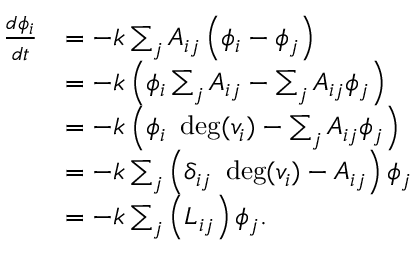<formula> <loc_0><loc_0><loc_500><loc_500>{ \begin{array} { r l } { { \frac { d \phi _ { i } } { d t } } } & { = - k \sum _ { j } A _ { i j } \left ( \phi _ { i } - \phi _ { j } \right ) } \\ & { = - k \left ( \phi _ { i } \sum _ { j } A _ { i j } - \sum _ { j } A _ { i j } \phi _ { j } \right ) } \\ & { = - k \left ( \phi _ { i } \ \deg ( v _ { i } ) - \sum _ { j } A _ { i j } \phi _ { j } \right ) } \\ & { = - k \sum _ { j } \left ( \delta _ { i j } \ \deg ( v _ { i } ) - A _ { i j } \right ) \phi _ { j } } \\ & { = - k \sum _ { j } \left ( L _ { i j } \right ) \phi _ { j } . } \end{array} }</formula> 